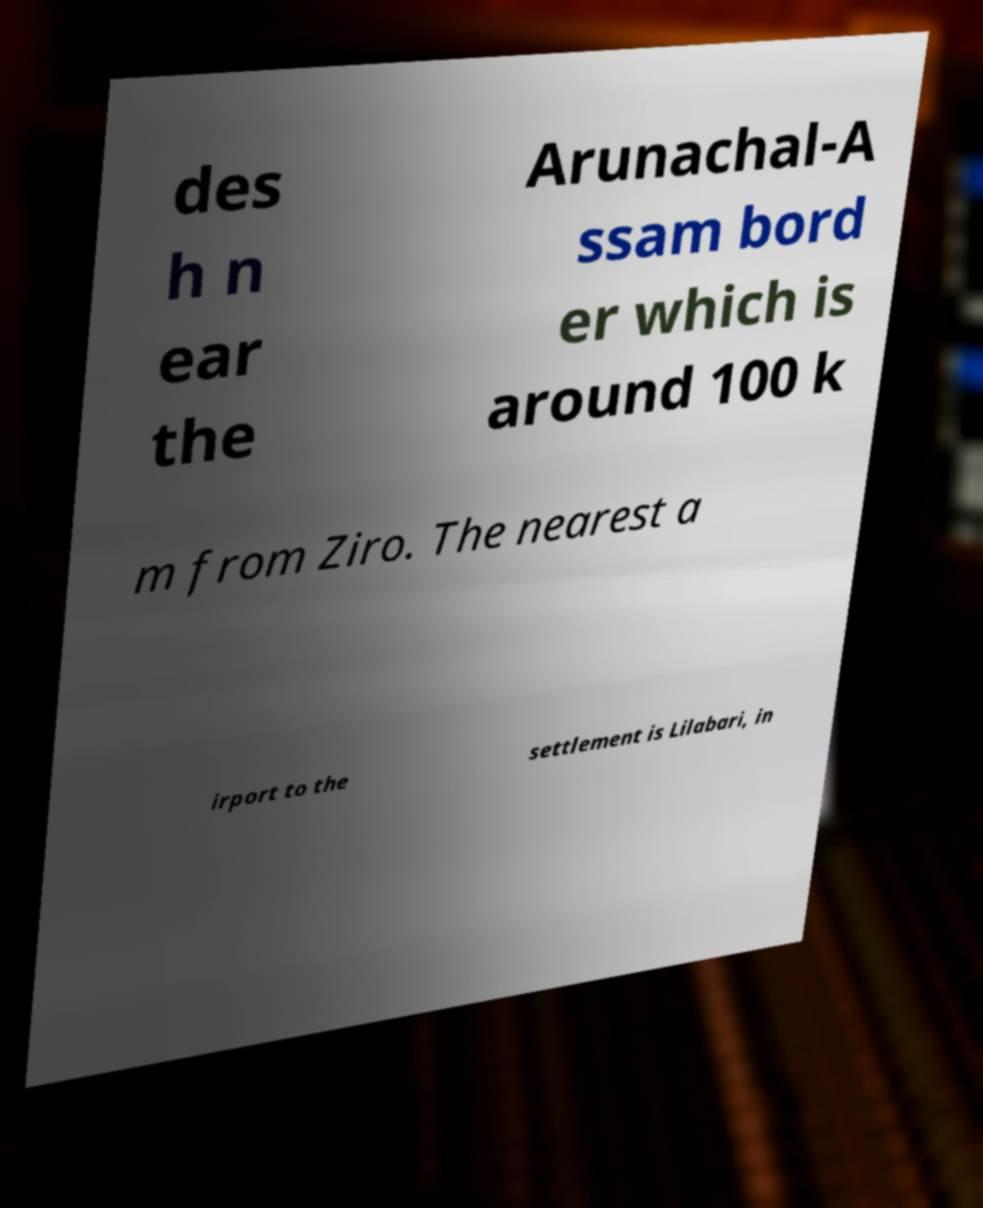Can you read and provide the text displayed in the image?This photo seems to have some interesting text. Can you extract and type it out for me? des h n ear the Arunachal-A ssam bord er which is around 100 k m from Ziro. The nearest a irport to the settlement is Lilabari, in 